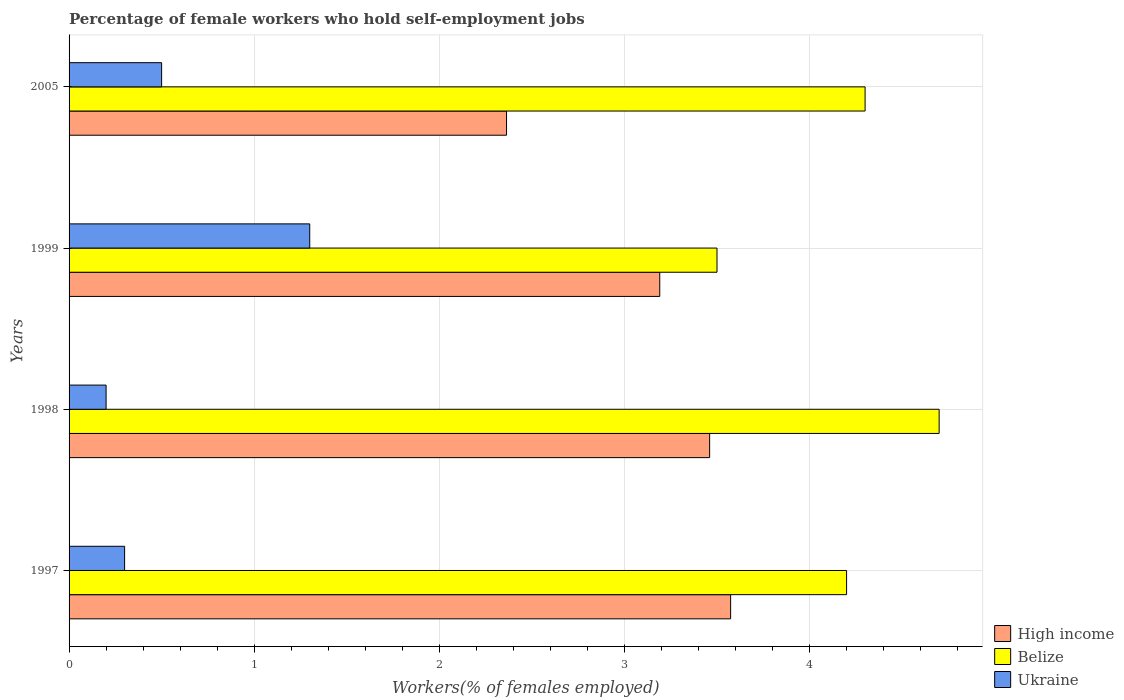Are the number of bars per tick equal to the number of legend labels?
Give a very brief answer. Yes. What is the percentage of self-employed female workers in High income in 2005?
Keep it short and to the point. 2.36. Across all years, what is the maximum percentage of self-employed female workers in High income?
Your answer should be compact. 3.57. Across all years, what is the minimum percentage of self-employed female workers in Ukraine?
Your answer should be very brief. 0.2. What is the total percentage of self-employed female workers in Ukraine in the graph?
Make the answer very short. 2.3. What is the difference between the percentage of self-employed female workers in High income in 1998 and that in 1999?
Provide a short and direct response. 0.27. What is the difference between the percentage of self-employed female workers in Belize in 1997 and the percentage of self-employed female workers in Ukraine in 1999?
Your answer should be compact. 2.9. What is the average percentage of self-employed female workers in Belize per year?
Provide a short and direct response. 4.17. In the year 2005, what is the difference between the percentage of self-employed female workers in Ukraine and percentage of self-employed female workers in High income?
Make the answer very short. -1.86. What is the ratio of the percentage of self-employed female workers in Belize in 1997 to that in 1998?
Keep it short and to the point. 0.89. Is the percentage of self-employed female workers in Belize in 1997 less than that in 1999?
Your response must be concise. No. Is the difference between the percentage of self-employed female workers in Ukraine in 1997 and 2005 greater than the difference between the percentage of self-employed female workers in High income in 1997 and 2005?
Your answer should be very brief. No. What is the difference between the highest and the second highest percentage of self-employed female workers in Ukraine?
Keep it short and to the point. 0.8. What is the difference between the highest and the lowest percentage of self-employed female workers in High income?
Your answer should be very brief. 1.21. In how many years, is the percentage of self-employed female workers in High income greater than the average percentage of self-employed female workers in High income taken over all years?
Your response must be concise. 3. What does the 1st bar from the top in 1998 represents?
Ensure brevity in your answer.  Ukraine. What does the 2nd bar from the bottom in 1999 represents?
Your answer should be compact. Belize. Is it the case that in every year, the sum of the percentage of self-employed female workers in Ukraine and percentage of self-employed female workers in Belize is greater than the percentage of self-employed female workers in High income?
Offer a terse response. Yes. How many bars are there?
Offer a very short reply. 12. How many years are there in the graph?
Your response must be concise. 4. What is the difference between two consecutive major ticks on the X-axis?
Provide a short and direct response. 1. Are the values on the major ticks of X-axis written in scientific E-notation?
Your answer should be compact. No. Does the graph contain any zero values?
Offer a very short reply. No. How are the legend labels stacked?
Provide a succinct answer. Vertical. What is the title of the graph?
Provide a short and direct response. Percentage of female workers who hold self-employment jobs. What is the label or title of the X-axis?
Your answer should be compact. Workers(% of females employed). What is the label or title of the Y-axis?
Make the answer very short. Years. What is the Workers(% of females employed) of High income in 1997?
Offer a terse response. 3.57. What is the Workers(% of females employed) of Belize in 1997?
Your response must be concise. 4.2. What is the Workers(% of females employed) in Ukraine in 1997?
Make the answer very short. 0.3. What is the Workers(% of females employed) in High income in 1998?
Give a very brief answer. 3.46. What is the Workers(% of females employed) of Belize in 1998?
Ensure brevity in your answer.  4.7. What is the Workers(% of females employed) of Ukraine in 1998?
Provide a short and direct response. 0.2. What is the Workers(% of females employed) of High income in 1999?
Your answer should be very brief. 3.19. What is the Workers(% of females employed) in Ukraine in 1999?
Provide a succinct answer. 1.3. What is the Workers(% of females employed) in High income in 2005?
Offer a very short reply. 2.36. What is the Workers(% of females employed) in Belize in 2005?
Keep it short and to the point. 4.3. What is the Workers(% of females employed) in Ukraine in 2005?
Your answer should be compact. 0.5. Across all years, what is the maximum Workers(% of females employed) in High income?
Provide a short and direct response. 3.57. Across all years, what is the maximum Workers(% of females employed) in Belize?
Keep it short and to the point. 4.7. Across all years, what is the maximum Workers(% of females employed) of Ukraine?
Your answer should be compact. 1.3. Across all years, what is the minimum Workers(% of females employed) of High income?
Ensure brevity in your answer.  2.36. Across all years, what is the minimum Workers(% of females employed) of Belize?
Give a very brief answer. 3.5. Across all years, what is the minimum Workers(% of females employed) in Ukraine?
Provide a succinct answer. 0.2. What is the total Workers(% of females employed) of High income in the graph?
Your response must be concise. 12.59. What is the total Workers(% of females employed) of Belize in the graph?
Offer a terse response. 16.7. What is the total Workers(% of females employed) in Ukraine in the graph?
Your answer should be compact. 2.3. What is the difference between the Workers(% of females employed) in High income in 1997 and that in 1998?
Your answer should be compact. 0.11. What is the difference between the Workers(% of females employed) of High income in 1997 and that in 1999?
Your answer should be very brief. 0.38. What is the difference between the Workers(% of females employed) in Belize in 1997 and that in 1999?
Provide a short and direct response. 0.7. What is the difference between the Workers(% of females employed) of Ukraine in 1997 and that in 1999?
Your answer should be compact. -1. What is the difference between the Workers(% of females employed) in High income in 1997 and that in 2005?
Give a very brief answer. 1.21. What is the difference between the Workers(% of females employed) in Ukraine in 1997 and that in 2005?
Provide a short and direct response. -0.2. What is the difference between the Workers(% of females employed) in High income in 1998 and that in 1999?
Provide a succinct answer. 0.27. What is the difference between the Workers(% of females employed) of Belize in 1998 and that in 1999?
Give a very brief answer. 1.2. What is the difference between the Workers(% of females employed) of High income in 1998 and that in 2005?
Your answer should be very brief. 1.1. What is the difference between the Workers(% of females employed) of Ukraine in 1998 and that in 2005?
Your response must be concise. -0.3. What is the difference between the Workers(% of females employed) in High income in 1999 and that in 2005?
Provide a succinct answer. 0.83. What is the difference between the Workers(% of females employed) of High income in 1997 and the Workers(% of females employed) of Belize in 1998?
Provide a succinct answer. -1.13. What is the difference between the Workers(% of females employed) in High income in 1997 and the Workers(% of females employed) in Ukraine in 1998?
Offer a very short reply. 3.37. What is the difference between the Workers(% of females employed) of High income in 1997 and the Workers(% of females employed) of Belize in 1999?
Provide a short and direct response. 0.07. What is the difference between the Workers(% of females employed) in High income in 1997 and the Workers(% of females employed) in Ukraine in 1999?
Ensure brevity in your answer.  2.27. What is the difference between the Workers(% of females employed) in High income in 1997 and the Workers(% of females employed) in Belize in 2005?
Your answer should be very brief. -0.73. What is the difference between the Workers(% of females employed) of High income in 1997 and the Workers(% of females employed) of Ukraine in 2005?
Provide a short and direct response. 3.07. What is the difference between the Workers(% of females employed) in Belize in 1997 and the Workers(% of females employed) in Ukraine in 2005?
Give a very brief answer. 3.7. What is the difference between the Workers(% of females employed) of High income in 1998 and the Workers(% of females employed) of Belize in 1999?
Your response must be concise. -0.04. What is the difference between the Workers(% of females employed) in High income in 1998 and the Workers(% of females employed) in Ukraine in 1999?
Your response must be concise. 2.16. What is the difference between the Workers(% of females employed) in High income in 1998 and the Workers(% of females employed) in Belize in 2005?
Give a very brief answer. -0.84. What is the difference between the Workers(% of females employed) of High income in 1998 and the Workers(% of females employed) of Ukraine in 2005?
Offer a terse response. 2.96. What is the difference between the Workers(% of females employed) in Belize in 1998 and the Workers(% of females employed) in Ukraine in 2005?
Provide a short and direct response. 4.2. What is the difference between the Workers(% of females employed) of High income in 1999 and the Workers(% of females employed) of Belize in 2005?
Offer a terse response. -1.11. What is the difference between the Workers(% of females employed) of High income in 1999 and the Workers(% of females employed) of Ukraine in 2005?
Give a very brief answer. 2.69. What is the average Workers(% of females employed) of High income per year?
Your response must be concise. 3.15. What is the average Workers(% of females employed) in Belize per year?
Ensure brevity in your answer.  4.17. What is the average Workers(% of females employed) in Ukraine per year?
Give a very brief answer. 0.57. In the year 1997, what is the difference between the Workers(% of females employed) in High income and Workers(% of females employed) in Belize?
Your answer should be very brief. -0.63. In the year 1997, what is the difference between the Workers(% of females employed) in High income and Workers(% of females employed) in Ukraine?
Your response must be concise. 3.27. In the year 1997, what is the difference between the Workers(% of females employed) in Belize and Workers(% of females employed) in Ukraine?
Your answer should be compact. 3.9. In the year 1998, what is the difference between the Workers(% of females employed) of High income and Workers(% of females employed) of Belize?
Ensure brevity in your answer.  -1.24. In the year 1998, what is the difference between the Workers(% of females employed) of High income and Workers(% of females employed) of Ukraine?
Provide a short and direct response. 3.26. In the year 1998, what is the difference between the Workers(% of females employed) in Belize and Workers(% of females employed) in Ukraine?
Provide a succinct answer. 4.5. In the year 1999, what is the difference between the Workers(% of females employed) of High income and Workers(% of females employed) of Belize?
Your answer should be very brief. -0.31. In the year 1999, what is the difference between the Workers(% of females employed) in High income and Workers(% of females employed) in Ukraine?
Offer a terse response. 1.89. In the year 2005, what is the difference between the Workers(% of females employed) of High income and Workers(% of females employed) of Belize?
Your answer should be compact. -1.94. In the year 2005, what is the difference between the Workers(% of females employed) of High income and Workers(% of females employed) of Ukraine?
Your answer should be compact. 1.86. What is the ratio of the Workers(% of females employed) of High income in 1997 to that in 1998?
Provide a succinct answer. 1.03. What is the ratio of the Workers(% of females employed) in Belize in 1997 to that in 1998?
Provide a succinct answer. 0.89. What is the ratio of the Workers(% of females employed) of Ukraine in 1997 to that in 1998?
Provide a succinct answer. 1.5. What is the ratio of the Workers(% of females employed) of High income in 1997 to that in 1999?
Ensure brevity in your answer.  1.12. What is the ratio of the Workers(% of females employed) in Belize in 1997 to that in 1999?
Your answer should be compact. 1.2. What is the ratio of the Workers(% of females employed) in Ukraine in 1997 to that in 1999?
Provide a short and direct response. 0.23. What is the ratio of the Workers(% of females employed) of High income in 1997 to that in 2005?
Your response must be concise. 1.51. What is the ratio of the Workers(% of females employed) of Belize in 1997 to that in 2005?
Keep it short and to the point. 0.98. What is the ratio of the Workers(% of females employed) of Ukraine in 1997 to that in 2005?
Ensure brevity in your answer.  0.6. What is the ratio of the Workers(% of females employed) in High income in 1998 to that in 1999?
Offer a terse response. 1.08. What is the ratio of the Workers(% of females employed) of Belize in 1998 to that in 1999?
Ensure brevity in your answer.  1.34. What is the ratio of the Workers(% of females employed) in Ukraine in 1998 to that in 1999?
Provide a short and direct response. 0.15. What is the ratio of the Workers(% of females employed) of High income in 1998 to that in 2005?
Provide a succinct answer. 1.46. What is the ratio of the Workers(% of females employed) in Belize in 1998 to that in 2005?
Your answer should be very brief. 1.09. What is the ratio of the Workers(% of females employed) of High income in 1999 to that in 2005?
Provide a short and direct response. 1.35. What is the ratio of the Workers(% of females employed) of Belize in 1999 to that in 2005?
Offer a terse response. 0.81. What is the ratio of the Workers(% of females employed) of Ukraine in 1999 to that in 2005?
Keep it short and to the point. 2.6. What is the difference between the highest and the second highest Workers(% of females employed) of High income?
Your answer should be compact. 0.11. What is the difference between the highest and the second highest Workers(% of females employed) of Belize?
Offer a very short reply. 0.4. What is the difference between the highest and the second highest Workers(% of females employed) in Ukraine?
Offer a terse response. 0.8. What is the difference between the highest and the lowest Workers(% of females employed) of High income?
Offer a very short reply. 1.21. 